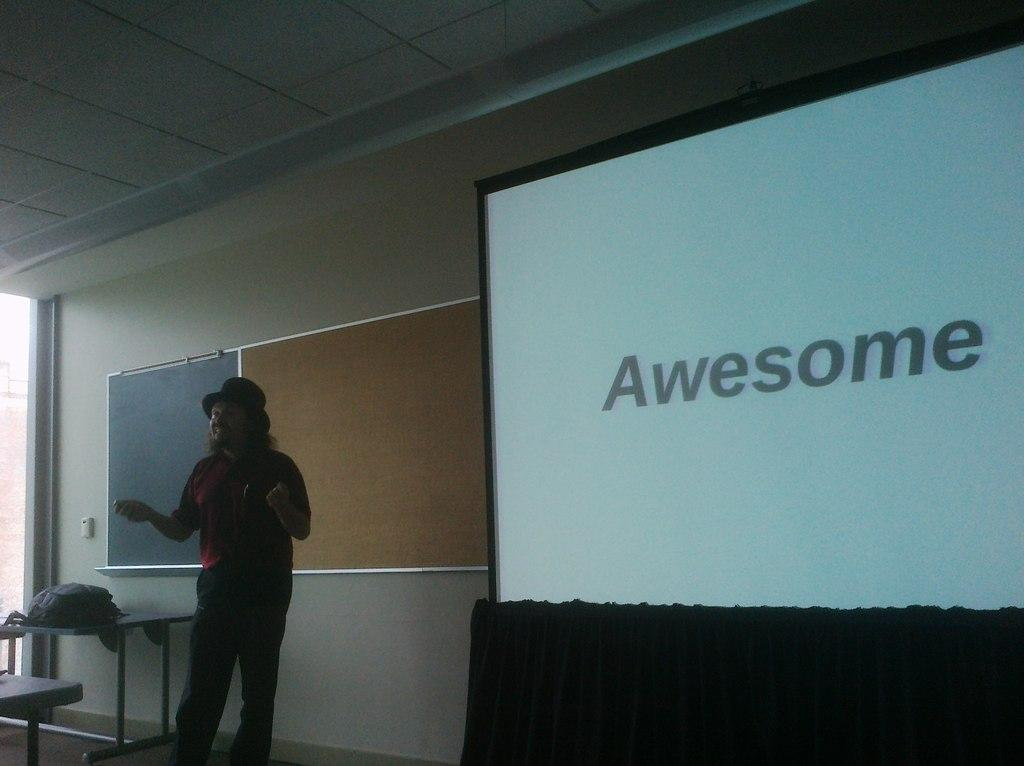What is the main subject of the image? There is a man standing in the image. Can you describe the man's attire? The man is wearing a hat. What objects can be seen in the image besides the man? There is a board, a projector screen on the wall, a bench, and a bag kept on the bench. Can you see any squirrels climbing the hill in the image? There is no hill or squirrel present in the image. What type of pump is being used to project the image on the screen? There is no pump visible in the image, and it is not mentioned that a pump is being used for projection. 